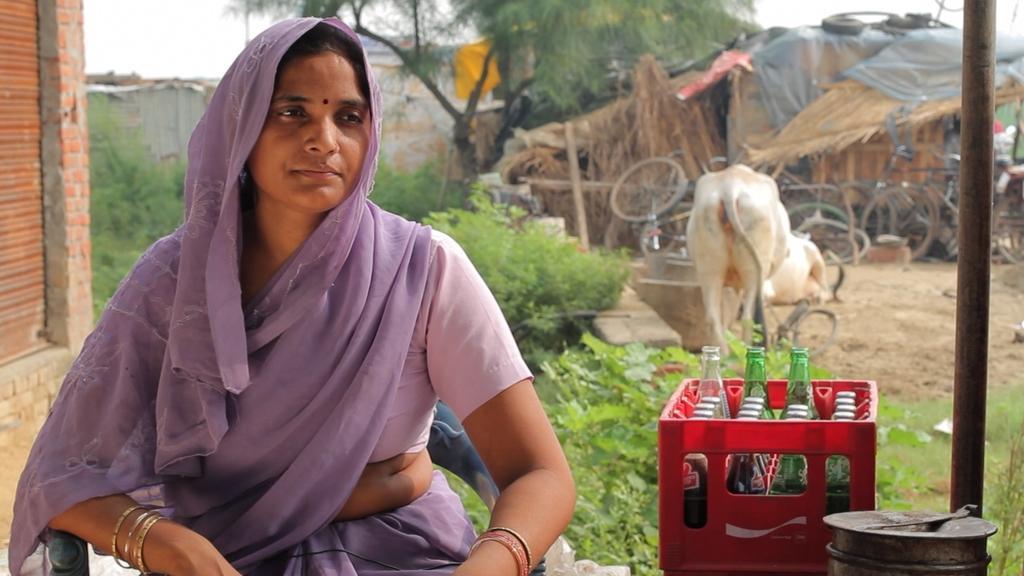How would you summarize this image in a sentence or two? This picture is clicked outside. On the left we can see a woman wearing saree and sitting on the chair. On the right we can see the bottles, basket, plants, metal rod and some other objects are placed on the ground and we can see the bicycles and an animal. In the background we can see the sky, trees, plants, shutter, huts and many other objects. 